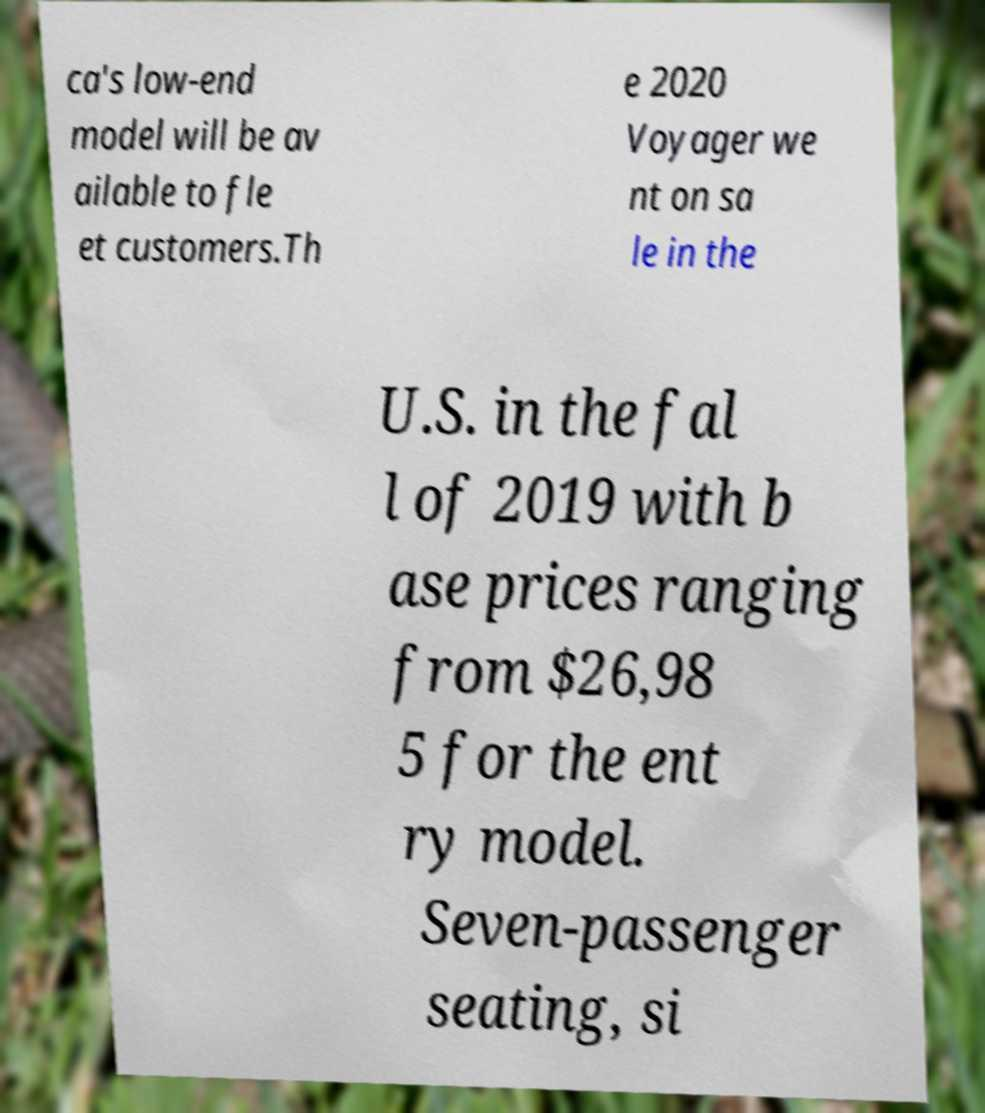Please read and relay the text visible in this image. What does it say? ca's low-end model will be av ailable to fle et customers.Th e 2020 Voyager we nt on sa le in the U.S. in the fal l of 2019 with b ase prices ranging from $26,98 5 for the ent ry model. Seven-passenger seating, si 